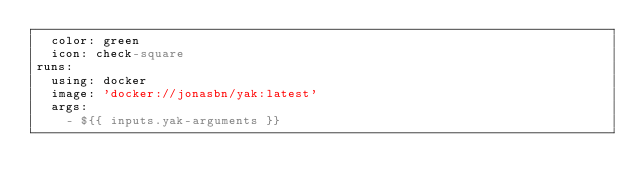Convert code to text. <code><loc_0><loc_0><loc_500><loc_500><_YAML_>  color: green
  icon: check-square
runs:
  using: docker
  image: 'docker://jonasbn/yak:latest'
  args:
    - ${{ inputs.yak-arguments }}
</code> 